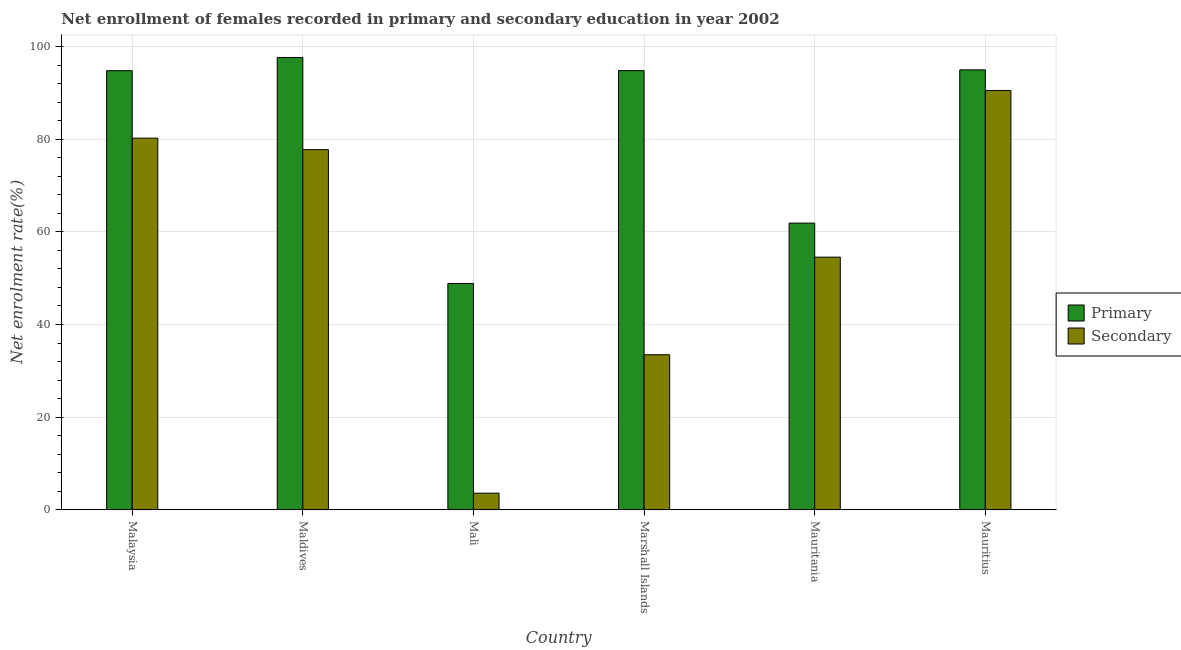How many groups of bars are there?
Offer a terse response. 6. Are the number of bars on each tick of the X-axis equal?
Your response must be concise. Yes. How many bars are there on the 2nd tick from the right?
Give a very brief answer. 2. What is the label of the 1st group of bars from the left?
Ensure brevity in your answer.  Malaysia. What is the enrollment rate in primary education in Maldives?
Ensure brevity in your answer.  97.65. Across all countries, what is the maximum enrollment rate in primary education?
Your answer should be compact. 97.65. Across all countries, what is the minimum enrollment rate in primary education?
Your response must be concise. 48.86. In which country was the enrollment rate in primary education maximum?
Offer a very short reply. Maldives. In which country was the enrollment rate in secondary education minimum?
Your response must be concise. Mali. What is the total enrollment rate in primary education in the graph?
Provide a succinct answer. 492.99. What is the difference between the enrollment rate in secondary education in Maldives and that in Mauritius?
Your response must be concise. -12.76. What is the difference between the enrollment rate in primary education in Marshall Islands and the enrollment rate in secondary education in Mauritania?
Make the answer very short. 40.27. What is the average enrollment rate in secondary education per country?
Ensure brevity in your answer.  56.68. What is the difference between the enrollment rate in secondary education and enrollment rate in primary education in Marshall Islands?
Ensure brevity in your answer.  -61.34. What is the ratio of the enrollment rate in primary education in Malaysia to that in Maldives?
Ensure brevity in your answer.  0.97. Is the difference between the enrollment rate in primary education in Maldives and Marshall Islands greater than the difference between the enrollment rate in secondary education in Maldives and Marshall Islands?
Keep it short and to the point. No. What is the difference between the highest and the second highest enrollment rate in primary education?
Provide a succinct answer. 2.67. What is the difference between the highest and the lowest enrollment rate in secondary education?
Your response must be concise. 86.93. In how many countries, is the enrollment rate in primary education greater than the average enrollment rate in primary education taken over all countries?
Keep it short and to the point. 4. Is the sum of the enrollment rate in primary education in Malaysia and Maldives greater than the maximum enrollment rate in secondary education across all countries?
Your answer should be compact. Yes. What does the 1st bar from the left in Mauritius represents?
Provide a succinct answer. Primary. What does the 2nd bar from the right in Malaysia represents?
Provide a succinct answer. Primary. How many bars are there?
Offer a very short reply. 12. Are all the bars in the graph horizontal?
Provide a succinct answer. No. How many countries are there in the graph?
Offer a very short reply. 6. Are the values on the major ticks of Y-axis written in scientific E-notation?
Provide a short and direct response. No. Does the graph contain grids?
Keep it short and to the point. Yes. How many legend labels are there?
Ensure brevity in your answer.  2. How are the legend labels stacked?
Offer a terse response. Vertical. What is the title of the graph?
Offer a very short reply. Net enrollment of females recorded in primary and secondary education in year 2002. What is the label or title of the Y-axis?
Your answer should be compact. Net enrolment rate(%). What is the Net enrolment rate(%) in Primary in Malaysia?
Offer a very short reply. 94.8. What is the Net enrolment rate(%) in Secondary in Malaysia?
Your response must be concise. 80.23. What is the Net enrolment rate(%) in Primary in Maldives?
Keep it short and to the point. 97.65. What is the Net enrolment rate(%) in Secondary in Maldives?
Ensure brevity in your answer.  77.75. What is the Net enrolment rate(%) in Primary in Mali?
Your answer should be compact. 48.86. What is the Net enrolment rate(%) in Secondary in Mali?
Make the answer very short. 3.58. What is the Net enrolment rate(%) of Primary in Marshall Islands?
Your answer should be very brief. 94.81. What is the Net enrolment rate(%) of Secondary in Marshall Islands?
Offer a very short reply. 33.47. What is the Net enrolment rate(%) in Primary in Mauritania?
Ensure brevity in your answer.  61.89. What is the Net enrolment rate(%) in Secondary in Mauritania?
Your answer should be compact. 54.54. What is the Net enrolment rate(%) in Primary in Mauritius?
Offer a very short reply. 94.98. What is the Net enrolment rate(%) of Secondary in Mauritius?
Keep it short and to the point. 90.51. Across all countries, what is the maximum Net enrolment rate(%) in Primary?
Your answer should be very brief. 97.65. Across all countries, what is the maximum Net enrolment rate(%) of Secondary?
Your answer should be compact. 90.51. Across all countries, what is the minimum Net enrolment rate(%) in Primary?
Your answer should be very brief. 48.86. Across all countries, what is the minimum Net enrolment rate(%) in Secondary?
Your answer should be very brief. 3.58. What is the total Net enrolment rate(%) of Primary in the graph?
Give a very brief answer. 492.99. What is the total Net enrolment rate(%) of Secondary in the graph?
Make the answer very short. 340.07. What is the difference between the Net enrolment rate(%) in Primary in Malaysia and that in Maldives?
Your answer should be compact. -2.85. What is the difference between the Net enrolment rate(%) in Secondary in Malaysia and that in Maldives?
Offer a terse response. 2.48. What is the difference between the Net enrolment rate(%) of Primary in Malaysia and that in Mali?
Offer a very short reply. 45.93. What is the difference between the Net enrolment rate(%) of Secondary in Malaysia and that in Mali?
Your answer should be very brief. 76.65. What is the difference between the Net enrolment rate(%) of Primary in Malaysia and that in Marshall Islands?
Keep it short and to the point. -0.02. What is the difference between the Net enrolment rate(%) of Secondary in Malaysia and that in Marshall Islands?
Your answer should be compact. 46.76. What is the difference between the Net enrolment rate(%) of Primary in Malaysia and that in Mauritania?
Keep it short and to the point. 32.91. What is the difference between the Net enrolment rate(%) of Secondary in Malaysia and that in Mauritania?
Provide a succinct answer. 25.69. What is the difference between the Net enrolment rate(%) of Primary in Malaysia and that in Mauritius?
Provide a succinct answer. -0.18. What is the difference between the Net enrolment rate(%) in Secondary in Malaysia and that in Mauritius?
Keep it short and to the point. -10.28. What is the difference between the Net enrolment rate(%) in Primary in Maldives and that in Mali?
Ensure brevity in your answer.  48.78. What is the difference between the Net enrolment rate(%) of Secondary in Maldives and that in Mali?
Your response must be concise. 74.17. What is the difference between the Net enrolment rate(%) of Primary in Maldives and that in Marshall Islands?
Give a very brief answer. 2.83. What is the difference between the Net enrolment rate(%) in Secondary in Maldives and that in Marshall Islands?
Make the answer very short. 44.28. What is the difference between the Net enrolment rate(%) of Primary in Maldives and that in Mauritania?
Offer a terse response. 35.75. What is the difference between the Net enrolment rate(%) in Secondary in Maldives and that in Mauritania?
Provide a short and direct response. 23.21. What is the difference between the Net enrolment rate(%) in Primary in Maldives and that in Mauritius?
Your answer should be compact. 2.67. What is the difference between the Net enrolment rate(%) in Secondary in Maldives and that in Mauritius?
Ensure brevity in your answer.  -12.76. What is the difference between the Net enrolment rate(%) in Primary in Mali and that in Marshall Islands?
Offer a terse response. -45.95. What is the difference between the Net enrolment rate(%) of Secondary in Mali and that in Marshall Islands?
Keep it short and to the point. -29.89. What is the difference between the Net enrolment rate(%) of Primary in Mali and that in Mauritania?
Make the answer very short. -13.03. What is the difference between the Net enrolment rate(%) of Secondary in Mali and that in Mauritania?
Give a very brief answer. -50.96. What is the difference between the Net enrolment rate(%) of Primary in Mali and that in Mauritius?
Your response must be concise. -46.12. What is the difference between the Net enrolment rate(%) of Secondary in Mali and that in Mauritius?
Your response must be concise. -86.93. What is the difference between the Net enrolment rate(%) of Primary in Marshall Islands and that in Mauritania?
Provide a succinct answer. 32.92. What is the difference between the Net enrolment rate(%) of Secondary in Marshall Islands and that in Mauritania?
Give a very brief answer. -21.07. What is the difference between the Net enrolment rate(%) in Primary in Marshall Islands and that in Mauritius?
Your answer should be very brief. -0.17. What is the difference between the Net enrolment rate(%) of Secondary in Marshall Islands and that in Mauritius?
Your answer should be compact. -57.04. What is the difference between the Net enrolment rate(%) of Primary in Mauritania and that in Mauritius?
Give a very brief answer. -33.09. What is the difference between the Net enrolment rate(%) in Secondary in Mauritania and that in Mauritius?
Offer a very short reply. -35.97. What is the difference between the Net enrolment rate(%) in Primary in Malaysia and the Net enrolment rate(%) in Secondary in Maldives?
Make the answer very short. 17.05. What is the difference between the Net enrolment rate(%) of Primary in Malaysia and the Net enrolment rate(%) of Secondary in Mali?
Your answer should be compact. 91.22. What is the difference between the Net enrolment rate(%) of Primary in Malaysia and the Net enrolment rate(%) of Secondary in Marshall Islands?
Your response must be concise. 61.33. What is the difference between the Net enrolment rate(%) in Primary in Malaysia and the Net enrolment rate(%) in Secondary in Mauritania?
Your answer should be very brief. 40.26. What is the difference between the Net enrolment rate(%) in Primary in Malaysia and the Net enrolment rate(%) in Secondary in Mauritius?
Offer a terse response. 4.29. What is the difference between the Net enrolment rate(%) in Primary in Maldives and the Net enrolment rate(%) in Secondary in Mali?
Ensure brevity in your answer.  94.07. What is the difference between the Net enrolment rate(%) in Primary in Maldives and the Net enrolment rate(%) in Secondary in Marshall Islands?
Provide a short and direct response. 64.17. What is the difference between the Net enrolment rate(%) of Primary in Maldives and the Net enrolment rate(%) of Secondary in Mauritania?
Your answer should be very brief. 43.11. What is the difference between the Net enrolment rate(%) of Primary in Maldives and the Net enrolment rate(%) of Secondary in Mauritius?
Make the answer very short. 7.14. What is the difference between the Net enrolment rate(%) in Primary in Mali and the Net enrolment rate(%) in Secondary in Marshall Islands?
Make the answer very short. 15.39. What is the difference between the Net enrolment rate(%) of Primary in Mali and the Net enrolment rate(%) of Secondary in Mauritania?
Offer a terse response. -5.68. What is the difference between the Net enrolment rate(%) in Primary in Mali and the Net enrolment rate(%) in Secondary in Mauritius?
Ensure brevity in your answer.  -41.64. What is the difference between the Net enrolment rate(%) of Primary in Marshall Islands and the Net enrolment rate(%) of Secondary in Mauritania?
Give a very brief answer. 40.27. What is the difference between the Net enrolment rate(%) in Primary in Marshall Islands and the Net enrolment rate(%) in Secondary in Mauritius?
Ensure brevity in your answer.  4.31. What is the difference between the Net enrolment rate(%) in Primary in Mauritania and the Net enrolment rate(%) in Secondary in Mauritius?
Keep it short and to the point. -28.62. What is the average Net enrolment rate(%) of Primary per country?
Your answer should be very brief. 82.16. What is the average Net enrolment rate(%) of Secondary per country?
Your answer should be compact. 56.68. What is the difference between the Net enrolment rate(%) of Primary and Net enrolment rate(%) of Secondary in Malaysia?
Keep it short and to the point. 14.57. What is the difference between the Net enrolment rate(%) of Primary and Net enrolment rate(%) of Secondary in Maldives?
Offer a very short reply. 19.9. What is the difference between the Net enrolment rate(%) of Primary and Net enrolment rate(%) of Secondary in Mali?
Provide a short and direct response. 45.28. What is the difference between the Net enrolment rate(%) of Primary and Net enrolment rate(%) of Secondary in Marshall Islands?
Your answer should be very brief. 61.34. What is the difference between the Net enrolment rate(%) in Primary and Net enrolment rate(%) in Secondary in Mauritania?
Give a very brief answer. 7.35. What is the difference between the Net enrolment rate(%) of Primary and Net enrolment rate(%) of Secondary in Mauritius?
Your answer should be very brief. 4.47. What is the ratio of the Net enrolment rate(%) of Primary in Malaysia to that in Maldives?
Make the answer very short. 0.97. What is the ratio of the Net enrolment rate(%) in Secondary in Malaysia to that in Maldives?
Your response must be concise. 1.03. What is the ratio of the Net enrolment rate(%) of Primary in Malaysia to that in Mali?
Provide a succinct answer. 1.94. What is the ratio of the Net enrolment rate(%) of Secondary in Malaysia to that in Mali?
Your answer should be compact. 22.41. What is the ratio of the Net enrolment rate(%) of Secondary in Malaysia to that in Marshall Islands?
Keep it short and to the point. 2.4. What is the ratio of the Net enrolment rate(%) of Primary in Malaysia to that in Mauritania?
Offer a very short reply. 1.53. What is the ratio of the Net enrolment rate(%) in Secondary in Malaysia to that in Mauritania?
Give a very brief answer. 1.47. What is the ratio of the Net enrolment rate(%) of Secondary in Malaysia to that in Mauritius?
Make the answer very short. 0.89. What is the ratio of the Net enrolment rate(%) in Primary in Maldives to that in Mali?
Ensure brevity in your answer.  2. What is the ratio of the Net enrolment rate(%) in Secondary in Maldives to that in Mali?
Offer a terse response. 21.72. What is the ratio of the Net enrolment rate(%) of Primary in Maldives to that in Marshall Islands?
Your response must be concise. 1.03. What is the ratio of the Net enrolment rate(%) of Secondary in Maldives to that in Marshall Islands?
Provide a succinct answer. 2.32. What is the ratio of the Net enrolment rate(%) of Primary in Maldives to that in Mauritania?
Your answer should be very brief. 1.58. What is the ratio of the Net enrolment rate(%) of Secondary in Maldives to that in Mauritania?
Make the answer very short. 1.43. What is the ratio of the Net enrolment rate(%) in Primary in Maldives to that in Mauritius?
Your answer should be very brief. 1.03. What is the ratio of the Net enrolment rate(%) in Secondary in Maldives to that in Mauritius?
Give a very brief answer. 0.86. What is the ratio of the Net enrolment rate(%) of Primary in Mali to that in Marshall Islands?
Offer a very short reply. 0.52. What is the ratio of the Net enrolment rate(%) of Secondary in Mali to that in Marshall Islands?
Your response must be concise. 0.11. What is the ratio of the Net enrolment rate(%) of Primary in Mali to that in Mauritania?
Make the answer very short. 0.79. What is the ratio of the Net enrolment rate(%) of Secondary in Mali to that in Mauritania?
Give a very brief answer. 0.07. What is the ratio of the Net enrolment rate(%) in Primary in Mali to that in Mauritius?
Keep it short and to the point. 0.51. What is the ratio of the Net enrolment rate(%) in Secondary in Mali to that in Mauritius?
Provide a short and direct response. 0.04. What is the ratio of the Net enrolment rate(%) of Primary in Marshall Islands to that in Mauritania?
Give a very brief answer. 1.53. What is the ratio of the Net enrolment rate(%) of Secondary in Marshall Islands to that in Mauritania?
Offer a terse response. 0.61. What is the ratio of the Net enrolment rate(%) in Secondary in Marshall Islands to that in Mauritius?
Ensure brevity in your answer.  0.37. What is the ratio of the Net enrolment rate(%) of Primary in Mauritania to that in Mauritius?
Your answer should be very brief. 0.65. What is the ratio of the Net enrolment rate(%) in Secondary in Mauritania to that in Mauritius?
Ensure brevity in your answer.  0.6. What is the difference between the highest and the second highest Net enrolment rate(%) in Primary?
Ensure brevity in your answer.  2.67. What is the difference between the highest and the second highest Net enrolment rate(%) in Secondary?
Make the answer very short. 10.28. What is the difference between the highest and the lowest Net enrolment rate(%) of Primary?
Keep it short and to the point. 48.78. What is the difference between the highest and the lowest Net enrolment rate(%) in Secondary?
Give a very brief answer. 86.93. 